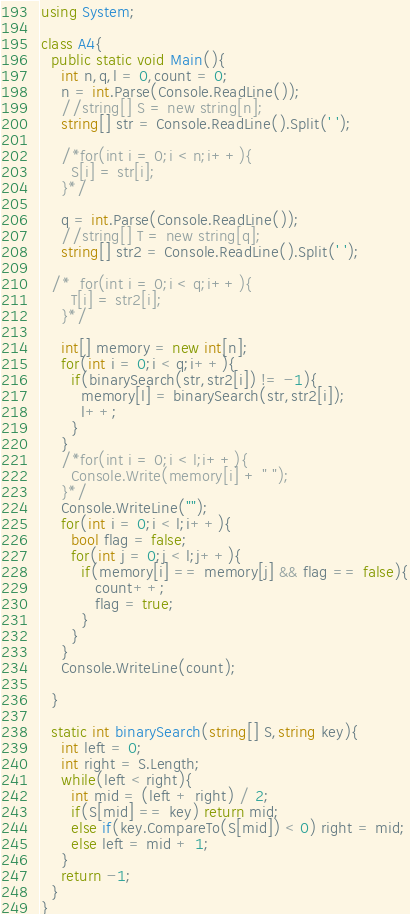Convert code to text. <code><loc_0><loc_0><loc_500><loc_500><_C#_>using System;

class A4{
  public static void Main(){
    int n,q,l = 0,count = 0;
    n = int.Parse(Console.ReadLine());
    //string[] S = new string[n];
    string[] str = Console.ReadLine().Split(' ');

    /*for(int i = 0;i < n;i++){
      S[i] = str[i];
    }*/

    q = int.Parse(Console.ReadLine());
    //string[] T = new string[q];
    string[] str2 = Console.ReadLine().Split(' ');

  /*  for(int i = 0;i < q;i++){
      T[i] = str2[i];
    }*/

    int[] memory = new int[n];
    for(int i = 0;i < q;i++){
      if(binarySearch(str,str2[i]) != -1){
        memory[l] = binarySearch(str,str2[i]);
        l++;
      }
    }
    /*for(int i = 0;i < l;i++){
      Console.Write(memory[i] + " ");
    }*/
    Console.WriteLine("");
    for(int i = 0;i < l;i++){
      bool flag = false;
      for(int j = 0;j < l;j++){
        if(memory[i] == memory[j] && flag == false){
           count++;
           flag = true;
        }
      }
    }
    Console.WriteLine(count);

  }

  static int binarySearch(string[] S,string key){
    int left = 0;
    int right = S.Length;
    while(left < right){
      int mid = (left + right) / 2;
      if(S[mid] == key) return mid;
      else if(key.CompareTo(S[mid]) < 0) right = mid;
      else left = mid + 1;
    }
    return -1;
  }
}
</code> 